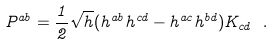Convert formula to latex. <formula><loc_0><loc_0><loc_500><loc_500>P ^ { a b } = \frac { 1 } { 2 } \sqrt { h } ( h ^ { a b } h ^ { c d } - h ^ { a c } h ^ { b d } ) K _ { c d } \ .</formula> 